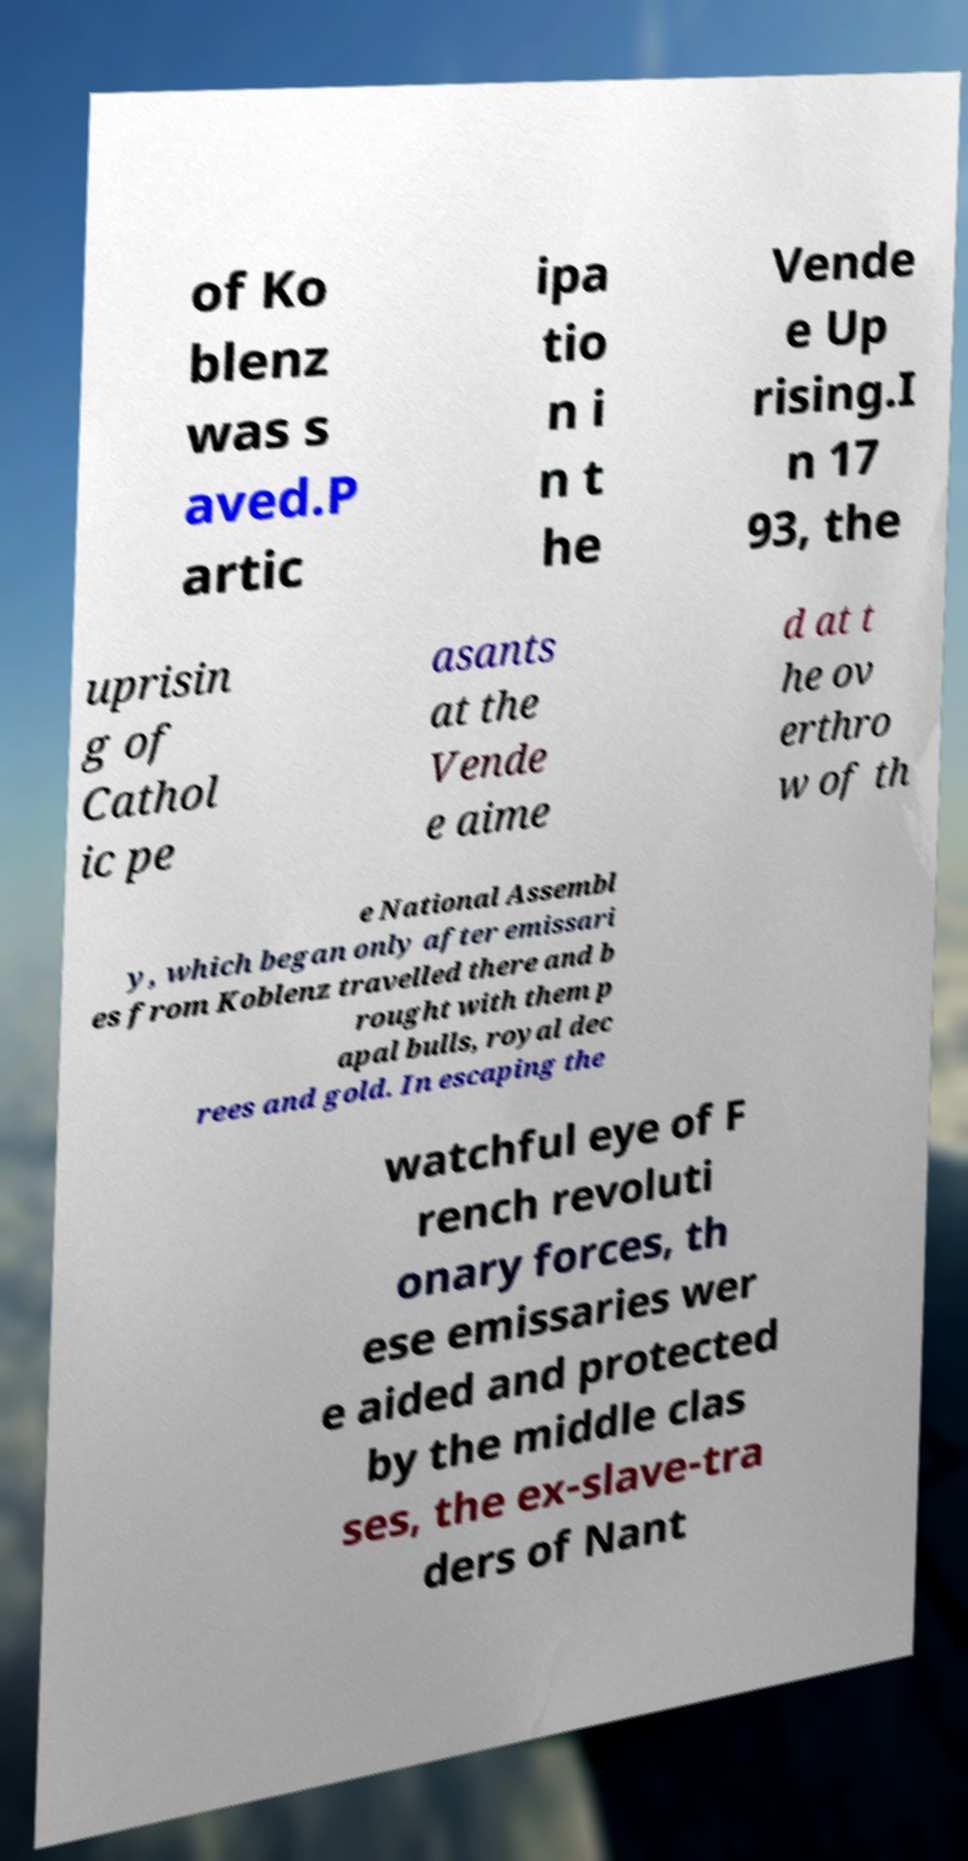Please identify and transcribe the text found in this image. of Ko blenz was s aved.P artic ipa tio n i n t he Vende e Up rising.I n 17 93, the uprisin g of Cathol ic pe asants at the Vende e aime d at t he ov erthro w of th e National Assembl y, which began only after emissari es from Koblenz travelled there and b rought with them p apal bulls, royal dec rees and gold. In escaping the watchful eye of F rench revoluti onary forces, th ese emissaries wer e aided and protected by the middle clas ses, the ex-slave-tra ders of Nant 